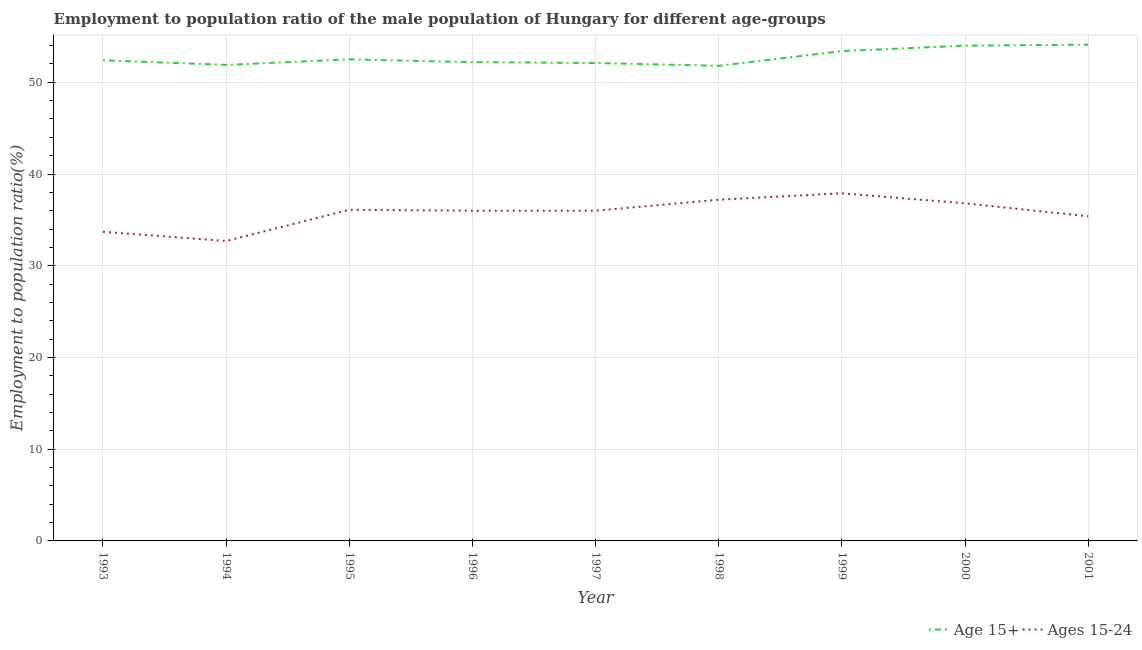How many different coloured lines are there?
Ensure brevity in your answer.  2. Is the number of lines equal to the number of legend labels?
Ensure brevity in your answer.  Yes. What is the employment to population ratio(age 15-24) in 1993?
Make the answer very short. 33.7. Across all years, what is the maximum employment to population ratio(age 15+)?
Give a very brief answer. 54.1. Across all years, what is the minimum employment to population ratio(age 15-24)?
Provide a short and direct response. 32.7. In which year was the employment to population ratio(age 15-24) minimum?
Provide a short and direct response. 1994. What is the total employment to population ratio(age 15-24) in the graph?
Give a very brief answer. 321.8. What is the difference between the employment to population ratio(age 15+) in 1994 and that in 1999?
Your answer should be compact. -1.5. What is the average employment to population ratio(age 15+) per year?
Your response must be concise. 52.71. In the year 2001, what is the difference between the employment to population ratio(age 15+) and employment to population ratio(age 15-24)?
Provide a short and direct response. 18.7. In how many years, is the employment to population ratio(age 15+) greater than 4 %?
Offer a very short reply. 9. What is the ratio of the employment to population ratio(age 15-24) in 1999 to that in 2001?
Ensure brevity in your answer.  1.07. Is the difference between the employment to population ratio(age 15-24) in 1994 and 1998 greater than the difference between the employment to population ratio(age 15+) in 1994 and 1998?
Provide a succinct answer. No. What is the difference between the highest and the second highest employment to population ratio(age 15-24)?
Give a very brief answer. 0.7. What is the difference between the highest and the lowest employment to population ratio(age 15+)?
Ensure brevity in your answer.  2.3. Is the employment to population ratio(age 15-24) strictly greater than the employment to population ratio(age 15+) over the years?
Keep it short and to the point. No. How many years are there in the graph?
Give a very brief answer. 9. Are the values on the major ticks of Y-axis written in scientific E-notation?
Provide a short and direct response. No. Does the graph contain any zero values?
Provide a short and direct response. No. What is the title of the graph?
Offer a terse response. Employment to population ratio of the male population of Hungary for different age-groups. Does "Female labor force" appear as one of the legend labels in the graph?
Offer a terse response. No. What is the Employment to population ratio(%) of Age 15+ in 1993?
Your answer should be very brief. 52.4. What is the Employment to population ratio(%) in Ages 15-24 in 1993?
Offer a very short reply. 33.7. What is the Employment to population ratio(%) in Age 15+ in 1994?
Ensure brevity in your answer.  51.9. What is the Employment to population ratio(%) of Ages 15-24 in 1994?
Provide a succinct answer. 32.7. What is the Employment to population ratio(%) in Age 15+ in 1995?
Offer a very short reply. 52.5. What is the Employment to population ratio(%) of Ages 15-24 in 1995?
Your answer should be very brief. 36.1. What is the Employment to population ratio(%) of Age 15+ in 1996?
Your answer should be compact. 52.2. What is the Employment to population ratio(%) of Age 15+ in 1997?
Your answer should be very brief. 52.1. What is the Employment to population ratio(%) in Ages 15-24 in 1997?
Make the answer very short. 36. What is the Employment to population ratio(%) in Age 15+ in 1998?
Offer a terse response. 51.8. What is the Employment to population ratio(%) in Ages 15-24 in 1998?
Your answer should be compact. 37.2. What is the Employment to population ratio(%) in Age 15+ in 1999?
Your answer should be compact. 53.4. What is the Employment to population ratio(%) in Ages 15-24 in 1999?
Your answer should be very brief. 37.9. What is the Employment to population ratio(%) of Ages 15-24 in 2000?
Your answer should be very brief. 36.8. What is the Employment to population ratio(%) of Age 15+ in 2001?
Offer a very short reply. 54.1. What is the Employment to population ratio(%) of Ages 15-24 in 2001?
Keep it short and to the point. 35.4. Across all years, what is the maximum Employment to population ratio(%) of Age 15+?
Your answer should be compact. 54.1. Across all years, what is the maximum Employment to population ratio(%) in Ages 15-24?
Make the answer very short. 37.9. Across all years, what is the minimum Employment to population ratio(%) in Age 15+?
Provide a short and direct response. 51.8. Across all years, what is the minimum Employment to population ratio(%) of Ages 15-24?
Offer a terse response. 32.7. What is the total Employment to population ratio(%) in Age 15+ in the graph?
Keep it short and to the point. 474.4. What is the total Employment to population ratio(%) in Ages 15-24 in the graph?
Ensure brevity in your answer.  321.8. What is the difference between the Employment to population ratio(%) in Age 15+ in 1993 and that in 1995?
Your response must be concise. -0.1. What is the difference between the Employment to population ratio(%) of Ages 15-24 in 1993 and that in 1996?
Provide a succinct answer. -2.3. What is the difference between the Employment to population ratio(%) of Age 15+ in 1993 and that in 1997?
Provide a short and direct response. 0.3. What is the difference between the Employment to population ratio(%) in Age 15+ in 1993 and that in 1998?
Your response must be concise. 0.6. What is the difference between the Employment to population ratio(%) in Ages 15-24 in 1993 and that in 1998?
Offer a terse response. -3.5. What is the difference between the Employment to population ratio(%) in Age 15+ in 1993 and that in 1999?
Your response must be concise. -1. What is the difference between the Employment to population ratio(%) of Age 15+ in 1993 and that in 2000?
Provide a short and direct response. -1.6. What is the difference between the Employment to population ratio(%) in Ages 15-24 in 1993 and that in 2000?
Offer a terse response. -3.1. What is the difference between the Employment to population ratio(%) in Age 15+ in 1993 and that in 2001?
Make the answer very short. -1.7. What is the difference between the Employment to population ratio(%) in Ages 15-24 in 1993 and that in 2001?
Offer a very short reply. -1.7. What is the difference between the Employment to population ratio(%) of Ages 15-24 in 1994 and that in 1995?
Provide a succinct answer. -3.4. What is the difference between the Employment to population ratio(%) of Age 15+ in 1994 and that in 1997?
Ensure brevity in your answer.  -0.2. What is the difference between the Employment to population ratio(%) of Ages 15-24 in 1994 and that in 1997?
Ensure brevity in your answer.  -3.3. What is the difference between the Employment to population ratio(%) of Ages 15-24 in 1994 and that in 1999?
Keep it short and to the point. -5.2. What is the difference between the Employment to population ratio(%) in Age 15+ in 1994 and that in 2000?
Offer a very short reply. -2.1. What is the difference between the Employment to population ratio(%) in Age 15+ in 1995 and that in 1996?
Make the answer very short. 0.3. What is the difference between the Employment to population ratio(%) in Age 15+ in 1995 and that in 1997?
Provide a short and direct response. 0.4. What is the difference between the Employment to population ratio(%) in Ages 15-24 in 1995 and that in 1998?
Ensure brevity in your answer.  -1.1. What is the difference between the Employment to population ratio(%) of Age 15+ in 1995 and that in 2000?
Your answer should be very brief. -1.5. What is the difference between the Employment to population ratio(%) of Ages 15-24 in 1995 and that in 2000?
Offer a terse response. -0.7. What is the difference between the Employment to population ratio(%) of Age 15+ in 1995 and that in 2001?
Your answer should be compact. -1.6. What is the difference between the Employment to population ratio(%) in Ages 15-24 in 1995 and that in 2001?
Provide a succinct answer. 0.7. What is the difference between the Employment to population ratio(%) in Age 15+ in 1996 and that in 1997?
Ensure brevity in your answer.  0.1. What is the difference between the Employment to population ratio(%) in Age 15+ in 1996 and that in 1998?
Your answer should be very brief. 0.4. What is the difference between the Employment to population ratio(%) in Ages 15-24 in 1996 and that in 1998?
Offer a terse response. -1.2. What is the difference between the Employment to population ratio(%) in Age 15+ in 1996 and that in 1999?
Your answer should be very brief. -1.2. What is the difference between the Employment to population ratio(%) of Ages 15-24 in 1996 and that in 1999?
Your answer should be compact. -1.9. What is the difference between the Employment to population ratio(%) of Age 15+ in 1996 and that in 2000?
Make the answer very short. -1.8. What is the difference between the Employment to population ratio(%) of Ages 15-24 in 1996 and that in 2000?
Ensure brevity in your answer.  -0.8. What is the difference between the Employment to population ratio(%) of Age 15+ in 1997 and that in 1998?
Keep it short and to the point. 0.3. What is the difference between the Employment to population ratio(%) in Ages 15-24 in 1997 and that in 1998?
Keep it short and to the point. -1.2. What is the difference between the Employment to population ratio(%) in Age 15+ in 1997 and that in 1999?
Make the answer very short. -1.3. What is the difference between the Employment to population ratio(%) in Ages 15-24 in 1997 and that in 1999?
Offer a terse response. -1.9. What is the difference between the Employment to population ratio(%) of Age 15+ in 1997 and that in 2000?
Give a very brief answer. -1.9. What is the difference between the Employment to population ratio(%) of Ages 15-24 in 1997 and that in 2000?
Provide a succinct answer. -0.8. What is the difference between the Employment to population ratio(%) of Age 15+ in 1997 and that in 2001?
Your response must be concise. -2. What is the difference between the Employment to population ratio(%) of Ages 15-24 in 1997 and that in 2001?
Your answer should be very brief. 0.6. What is the difference between the Employment to population ratio(%) of Age 15+ in 1998 and that in 1999?
Ensure brevity in your answer.  -1.6. What is the difference between the Employment to population ratio(%) of Ages 15-24 in 1998 and that in 1999?
Give a very brief answer. -0.7. What is the difference between the Employment to population ratio(%) in Ages 15-24 in 1998 and that in 2000?
Make the answer very short. 0.4. What is the difference between the Employment to population ratio(%) in Ages 15-24 in 1998 and that in 2001?
Offer a very short reply. 1.8. What is the difference between the Employment to population ratio(%) in Age 15+ in 1999 and that in 2000?
Keep it short and to the point. -0.6. What is the difference between the Employment to population ratio(%) in Age 15+ in 1999 and that in 2001?
Offer a terse response. -0.7. What is the difference between the Employment to population ratio(%) in Ages 15-24 in 1999 and that in 2001?
Your answer should be compact. 2.5. What is the difference between the Employment to population ratio(%) in Age 15+ in 1993 and the Employment to population ratio(%) in Ages 15-24 in 1995?
Your answer should be compact. 16.3. What is the difference between the Employment to population ratio(%) in Age 15+ in 1993 and the Employment to population ratio(%) in Ages 15-24 in 1998?
Give a very brief answer. 15.2. What is the difference between the Employment to population ratio(%) of Age 15+ in 1993 and the Employment to population ratio(%) of Ages 15-24 in 1999?
Make the answer very short. 14.5. What is the difference between the Employment to population ratio(%) in Age 15+ in 1994 and the Employment to population ratio(%) in Ages 15-24 in 1996?
Give a very brief answer. 15.9. What is the difference between the Employment to population ratio(%) in Age 15+ in 1994 and the Employment to population ratio(%) in Ages 15-24 in 2001?
Offer a very short reply. 16.5. What is the difference between the Employment to population ratio(%) in Age 15+ in 1995 and the Employment to population ratio(%) in Ages 15-24 in 1996?
Make the answer very short. 16.5. What is the difference between the Employment to population ratio(%) of Age 15+ in 1995 and the Employment to population ratio(%) of Ages 15-24 in 1999?
Keep it short and to the point. 14.6. What is the difference between the Employment to population ratio(%) in Age 15+ in 1996 and the Employment to population ratio(%) in Ages 15-24 in 1998?
Ensure brevity in your answer.  15. What is the difference between the Employment to population ratio(%) of Age 15+ in 1996 and the Employment to population ratio(%) of Ages 15-24 in 1999?
Keep it short and to the point. 14.3. What is the difference between the Employment to population ratio(%) in Age 15+ in 1997 and the Employment to population ratio(%) in Ages 15-24 in 1999?
Provide a short and direct response. 14.2. What is the difference between the Employment to population ratio(%) in Age 15+ in 1997 and the Employment to population ratio(%) in Ages 15-24 in 2000?
Your response must be concise. 15.3. What is the difference between the Employment to population ratio(%) of Age 15+ in 1998 and the Employment to population ratio(%) of Ages 15-24 in 2000?
Ensure brevity in your answer.  15. What is the difference between the Employment to population ratio(%) in Age 15+ in 1999 and the Employment to population ratio(%) in Ages 15-24 in 2000?
Your answer should be compact. 16.6. What is the average Employment to population ratio(%) of Age 15+ per year?
Ensure brevity in your answer.  52.71. What is the average Employment to population ratio(%) of Ages 15-24 per year?
Your answer should be compact. 35.76. In the year 1993, what is the difference between the Employment to population ratio(%) of Age 15+ and Employment to population ratio(%) of Ages 15-24?
Offer a terse response. 18.7. In the year 1995, what is the difference between the Employment to population ratio(%) of Age 15+ and Employment to population ratio(%) of Ages 15-24?
Your answer should be very brief. 16.4. In the year 1996, what is the difference between the Employment to population ratio(%) of Age 15+ and Employment to population ratio(%) of Ages 15-24?
Your answer should be compact. 16.2. In the year 1997, what is the difference between the Employment to population ratio(%) of Age 15+ and Employment to population ratio(%) of Ages 15-24?
Provide a succinct answer. 16.1. In the year 1998, what is the difference between the Employment to population ratio(%) in Age 15+ and Employment to population ratio(%) in Ages 15-24?
Your answer should be very brief. 14.6. In the year 2001, what is the difference between the Employment to population ratio(%) in Age 15+ and Employment to population ratio(%) in Ages 15-24?
Offer a very short reply. 18.7. What is the ratio of the Employment to population ratio(%) of Age 15+ in 1993 to that in 1994?
Give a very brief answer. 1.01. What is the ratio of the Employment to population ratio(%) in Ages 15-24 in 1993 to that in 1994?
Your response must be concise. 1.03. What is the ratio of the Employment to population ratio(%) of Age 15+ in 1993 to that in 1995?
Offer a terse response. 1. What is the ratio of the Employment to population ratio(%) of Ages 15-24 in 1993 to that in 1995?
Give a very brief answer. 0.93. What is the ratio of the Employment to population ratio(%) of Ages 15-24 in 1993 to that in 1996?
Your response must be concise. 0.94. What is the ratio of the Employment to population ratio(%) of Ages 15-24 in 1993 to that in 1997?
Ensure brevity in your answer.  0.94. What is the ratio of the Employment to population ratio(%) in Age 15+ in 1993 to that in 1998?
Ensure brevity in your answer.  1.01. What is the ratio of the Employment to population ratio(%) of Ages 15-24 in 1993 to that in 1998?
Give a very brief answer. 0.91. What is the ratio of the Employment to population ratio(%) in Age 15+ in 1993 to that in 1999?
Provide a short and direct response. 0.98. What is the ratio of the Employment to population ratio(%) in Ages 15-24 in 1993 to that in 1999?
Your answer should be very brief. 0.89. What is the ratio of the Employment to population ratio(%) in Age 15+ in 1993 to that in 2000?
Provide a short and direct response. 0.97. What is the ratio of the Employment to population ratio(%) in Ages 15-24 in 1993 to that in 2000?
Give a very brief answer. 0.92. What is the ratio of the Employment to population ratio(%) of Age 15+ in 1993 to that in 2001?
Ensure brevity in your answer.  0.97. What is the ratio of the Employment to population ratio(%) in Age 15+ in 1994 to that in 1995?
Make the answer very short. 0.99. What is the ratio of the Employment to population ratio(%) of Ages 15-24 in 1994 to that in 1995?
Your answer should be very brief. 0.91. What is the ratio of the Employment to population ratio(%) of Age 15+ in 1994 to that in 1996?
Provide a succinct answer. 0.99. What is the ratio of the Employment to population ratio(%) in Ages 15-24 in 1994 to that in 1996?
Make the answer very short. 0.91. What is the ratio of the Employment to population ratio(%) in Age 15+ in 1994 to that in 1997?
Offer a terse response. 1. What is the ratio of the Employment to population ratio(%) in Ages 15-24 in 1994 to that in 1997?
Your answer should be very brief. 0.91. What is the ratio of the Employment to population ratio(%) of Ages 15-24 in 1994 to that in 1998?
Give a very brief answer. 0.88. What is the ratio of the Employment to population ratio(%) of Age 15+ in 1994 to that in 1999?
Give a very brief answer. 0.97. What is the ratio of the Employment to population ratio(%) in Ages 15-24 in 1994 to that in 1999?
Your answer should be very brief. 0.86. What is the ratio of the Employment to population ratio(%) of Age 15+ in 1994 to that in 2000?
Ensure brevity in your answer.  0.96. What is the ratio of the Employment to population ratio(%) of Ages 15-24 in 1994 to that in 2000?
Your answer should be very brief. 0.89. What is the ratio of the Employment to population ratio(%) of Age 15+ in 1994 to that in 2001?
Make the answer very short. 0.96. What is the ratio of the Employment to population ratio(%) of Ages 15-24 in 1994 to that in 2001?
Your answer should be compact. 0.92. What is the ratio of the Employment to population ratio(%) of Age 15+ in 1995 to that in 1997?
Give a very brief answer. 1.01. What is the ratio of the Employment to population ratio(%) of Ages 15-24 in 1995 to that in 1997?
Ensure brevity in your answer.  1. What is the ratio of the Employment to population ratio(%) of Age 15+ in 1995 to that in 1998?
Make the answer very short. 1.01. What is the ratio of the Employment to population ratio(%) of Ages 15-24 in 1995 to that in 1998?
Provide a succinct answer. 0.97. What is the ratio of the Employment to population ratio(%) in Age 15+ in 1995 to that in 1999?
Offer a terse response. 0.98. What is the ratio of the Employment to population ratio(%) in Ages 15-24 in 1995 to that in 1999?
Provide a succinct answer. 0.95. What is the ratio of the Employment to population ratio(%) in Age 15+ in 1995 to that in 2000?
Your answer should be very brief. 0.97. What is the ratio of the Employment to population ratio(%) of Ages 15-24 in 1995 to that in 2000?
Your answer should be very brief. 0.98. What is the ratio of the Employment to population ratio(%) of Age 15+ in 1995 to that in 2001?
Ensure brevity in your answer.  0.97. What is the ratio of the Employment to population ratio(%) in Ages 15-24 in 1995 to that in 2001?
Provide a short and direct response. 1.02. What is the ratio of the Employment to population ratio(%) of Ages 15-24 in 1996 to that in 1997?
Ensure brevity in your answer.  1. What is the ratio of the Employment to population ratio(%) in Age 15+ in 1996 to that in 1998?
Ensure brevity in your answer.  1.01. What is the ratio of the Employment to population ratio(%) in Age 15+ in 1996 to that in 1999?
Ensure brevity in your answer.  0.98. What is the ratio of the Employment to population ratio(%) of Ages 15-24 in 1996 to that in 1999?
Your answer should be very brief. 0.95. What is the ratio of the Employment to population ratio(%) in Age 15+ in 1996 to that in 2000?
Offer a terse response. 0.97. What is the ratio of the Employment to population ratio(%) of Ages 15-24 in 1996 to that in 2000?
Ensure brevity in your answer.  0.98. What is the ratio of the Employment to population ratio(%) in Age 15+ in 1996 to that in 2001?
Ensure brevity in your answer.  0.96. What is the ratio of the Employment to population ratio(%) of Ages 15-24 in 1996 to that in 2001?
Keep it short and to the point. 1.02. What is the ratio of the Employment to population ratio(%) in Age 15+ in 1997 to that in 1998?
Provide a short and direct response. 1.01. What is the ratio of the Employment to population ratio(%) in Age 15+ in 1997 to that in 1999?
Give a very brief answer. 0.98. What is the ratio of the Employment to population ratio(%) in Ages 15-24 in 1997 to that in 1999?
Offer a very short reply. 0.95. What is the ratio of the Employment to population ratio(%) of Age 15+ in 1997 to that in 2000?
Your answer should be very brief. 0.96. What is the ratio of the Employment to population ratio(%) in Ages 15-24 in 1997 to that in 2000?
Your answer should be compact. 0.98. What is the ratio of the Employment to population ratio(%) in Age 15+ in 1997 to that in 2001?
Ensure brevity in your answer.  0.96. What is the ratio of the Employment to population ratio(%) of Ages 15-24 in 1997 to that in 2001?
Give a very brief answer. 1.02. What is the ratio of the Employment to population ratio(%) of Ages 15-24 in 1998 to that in 1999?
Keep it short and to the point. 0.98. What is the ratio of the Employment to population ratio(%) in Age 15+ in 1998 to that in 2000?
Ensure brevity in your answer.  0.96. What is the ratio of the Employment to population ratio(%) in Ages 15-24 in 1998 to that in 2000?
Provide a short and direct response. 1.01. What is the ratio of the Employment to population ratio(%) of Age 15+ in 1998 to that in 2001?
Give a very brief answer. 0.96. What is the ratio of the Employment to population ratio(%) of Ages 15-24 in 1998 to that in 2001?
Offer a very short reply. 1.05. What is the ratio of the Employment to population ratio(%) in Age 15+ in 1999 to that in 2000?
Your answer should be very brief. 0.99. What is the ratio of the Employment to population ratio(%) in Ages 15-24 in 1999 to that in 2000?
Your answer should be compact. 1.03. What is the ratio of the Employment to population ratio(%) in Age 15+ in 1999 to that in 2001?
Ensure brevity in your answer.  0.99. What is the ratio of the Employment to population ratio(%) of Ages 15-24 in 1999 to that in 2001?
Give a very brief answer. 1.07. What is the ratio of the Employment to population ratio(%) in Age 15+ in 2000 to that in 2001?
Ensure brevity in your answer.  1. What is the ratio of the Employment to population ratio(%) in Ages 15-24 in 2000 to that in 2001?
Your answer should be compact. 1.04. What is the difference between the highest and the second highest Employment to population ratio(%) of Ages 15-24?
Keep it short and to the point. 0.7. 